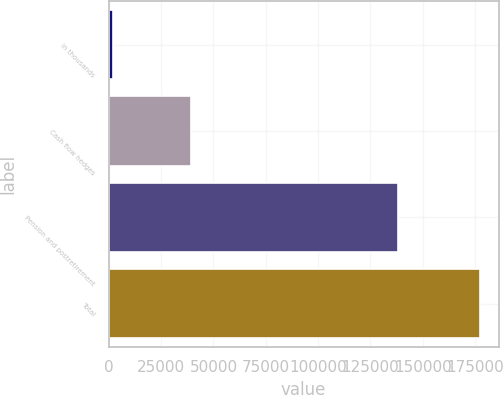Convert chart. <chart><loc_0><loc_0><loc_500><loc_500><bar_chart><fcel>in thousands<fcel>Cash flow hedges<fcel>Pension and postretirement<fcel>Total<nl><fcel>2010<fcel>39137<fcel>138202<fcel>177339<nl></chart> 